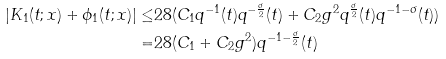<formula> <loc_0><loc_0><loc_500><loc_500>| K _ { 1 } ( t ; x ) + \phi _ { 1 } ( t ; x ) | \leq & 2 8 ( C _ { 1 } q ^ { - 1 } ( t ) q ^ { - \frac { \sigma } { 2 } } ( t ) + C _ { 2 } g ^ { 2 } q ^ { \frac { \sigma } { 2 } } ( t ) q ^ { - 1 - \sigma } ( t ) ) \\ = & 2 8 ( C _ { 1 } + C _ { 2 } g ^ { 2 } ) q ^ { - 1 - \frac { \sigma } { 2 } } ( t )</formula> 